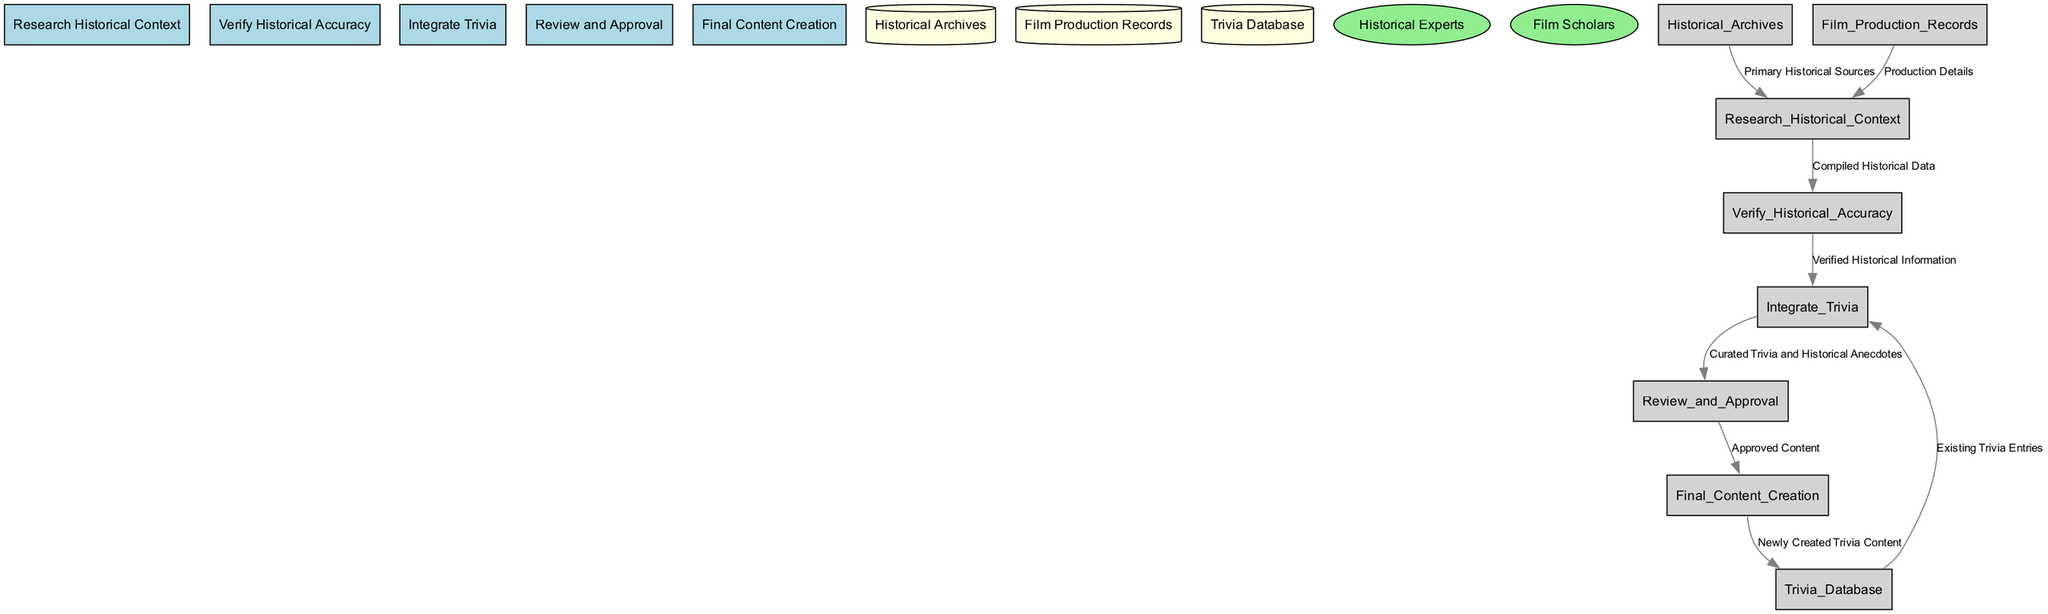What is the first process in the diagram? The first process listed in the diagram is "Research Historical Context." Since it is presented as the initial step among the processes, it indicates the starting point of the historical fact-checking workflow.
Answer: Research Historical Context How many processes are in the diagram? There are five processes listed in the diagram. Counting each of the processes outlined confirms this number.
Answer: 5 What type of data does "Verify Historical Accuracy" receive? "Verify Historical Accuracy" receives "Compiled Historical Data" as its input data, which is generated from the preceding process "Research Historical Context." This relationship indicates what information is passed along to the next step.
Answer: Compiled Historical Data Which data store provides "Primary Historical Sources"? "Historical Archives" is the data store that provides "Primary Historical Sources" to the "Research Historical Context" process. This is shown in the relationship where the data flow originates from the data store to the process.
Answer: Historical Archives Which processes are involved in the integration of trivia? The processes involved in integrating trivia are "Integrate Trivia" and "Review and Approval." "Integrate Trivia" collects information to be reviewed and then forwards it to "Review and Approval" for validation. This flow of information highlights the two relevant processes in the overall workflow.
Answer: Integrate Trivia, Review and Approval What external entity verifies the historical accuracy of the information? The external entity responsible for verifying the historical accuracy is "Historical Experts." This is indicated in the diagram as part of the process flow that includes approval and fact-checking of the integrated content.
Answer: Historical Experts What data flows into "Final Content Creation"? The data that flows into "Final Content Creation" is "Approved Content." This indicates that all necessary information has been validated before moving on to create the final materials.
Answer: Approved Content How many data stores are present in the diagram? There are three data stores present in the diagram. Each data store is clearly annotated in the structure, contributing to the overall data flow and context of the processes.
Answer: 3 Which process comes before "Review and Approval"? The process that comes before "Review and Approval" is "Integrate Trivia." The diagram illustrates a direct flow from "Integrate Trivia" to "Review and Approval," indicating the sequence of processes.
Answer: Integrate Trivia What is the output of the "Final Content Creation" process? The output of the "Final Content Creation" process is "Newly Created Trivia Content." This indicates what results from the final step of the content creation phase in the workflow.
Answer: Newly Created Trivia Content 